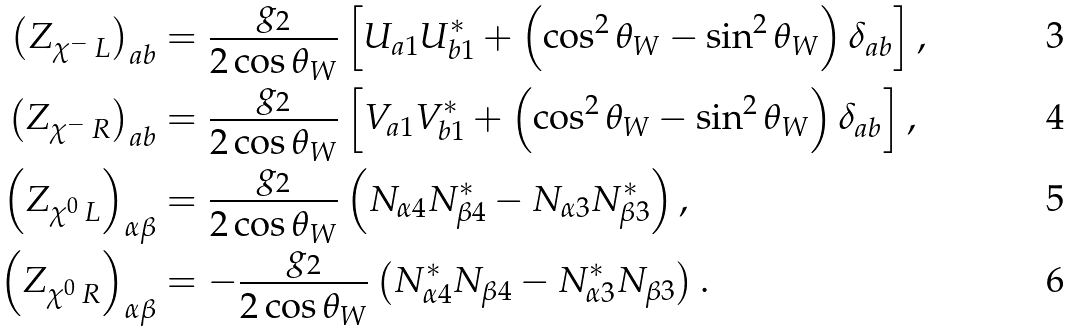Convert formula to latex. <formula><loc_0><loc_0><loc_500><loc_500>\left ( Z _ { \chi ^ { - } \, L } \right ) _ { a b } & = \frac { g _ { 2 } } { 2 \cos \theta _ { W } } \left [ U _ { a 1 } U _ { b 1 } ^ { \ast } + \left ( \cos ^ { 2 } \theta _ { W } - \sin ^ { 2 } \theta _ { W } \right ) \delta _ { a b } \right ] , \\ \left ( Z _ { \chi ^ { - } \, R } \right ) _ { a b } & = \frac { g _ { 2 } } { 2 \cos \theta _ { W } } \left [ V _ { a 1 } V _ { b 1 } ^ { \ast } + \left ( \cos ^ { 2 } \theta _ { W } - \sin ^ { 2 } \theta _ { W } \right ) \delta _ { a b } \right ] , \\ \left ( Z _ { \chi ^ { 0 } \, L } \right ) _ { \alpha \beta } & = \frac { g _ { 2 } } { 2 \cos \theta _ { W } } \left ( N _ { \alpha 4 } N _ { \beta 4 } ^ { \ast } - N _ { \alpha 3 } N _ { \beta 3 } ^ { \ast } \right ) , \\ \left ( Z _ { \chi ^ { 0 } \, R } \right ) _ { \alpha \beta } & = - \frac { g _ { 2 } } { 2 \cos \theta _ { W } } \left ( N _ { \alpha 4 } ^ { \ast } N _ { \beta 4 } - N _ { \alpha 3 } ^ { \ast } N _ { \beta 3 } \right ) .</formula> 